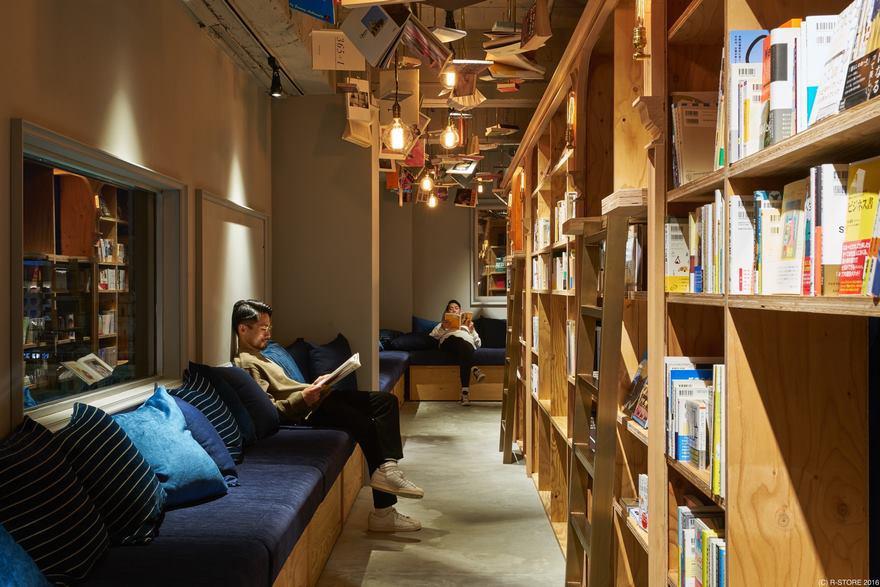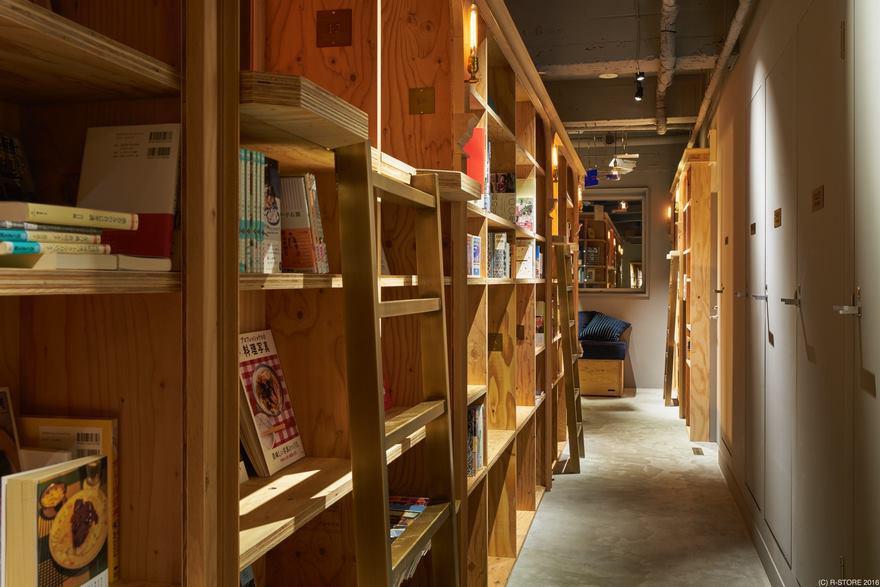The first image is the image on the left, the second image is the image on the right. Examine the images to the left and right. Is the description "There is someone sitting on a blue cushion." accurate? Answer yes or no. Yes. 